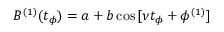<formula> <loc_0><loc_0><loc_500><loc_500>B ^ { ( 1 ) } ( t _ { \phi } ) = a + b \cos { [ \nu t _ { \phi } + \phi ^ { ( 1 ) } ] }</formula> 